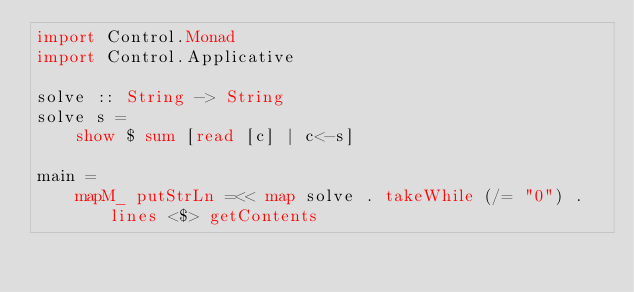<code> <loc_0><loc_0><loc_500><loc_500><_Haskell_>import Control.Monad
import Control.Applicative

solve :: String -> String
solve s =
    show $ sum [read [c] | c<-s]

main =
    mapM_ putStrLn =<< map solve . takeWhile (/= "0") . lines <$> getContents 
</code> 